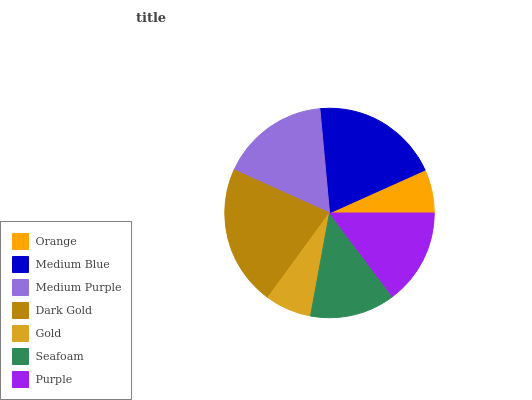Is Orange the minimum?
Answer yes or no. Yes. Is Dark Gold the maximum?
Answer yes or no. Yes. Is Medium Blue the minimum?
Answer yes or no. No. Is Medium Blue the maximum?
Answer yes or no. No. Is Medium Blue greater than Orange?
Answer yes or no. Yes. Is Orange less than Medium Blue?
Answer yes or no. Yes. Is Orange greater than Medium Blue?
Answer yes or no. No. Is Medium Blue less than Orange?
Answer yes or no. No. Is Purple the high median?
Answer yes or no. Yes. Is Purple the low median?
Answer yes or no. Yes. Is Gold the high median?
Answer yes or no. No. Is Gold the low median?
Answer yes or no. No. 